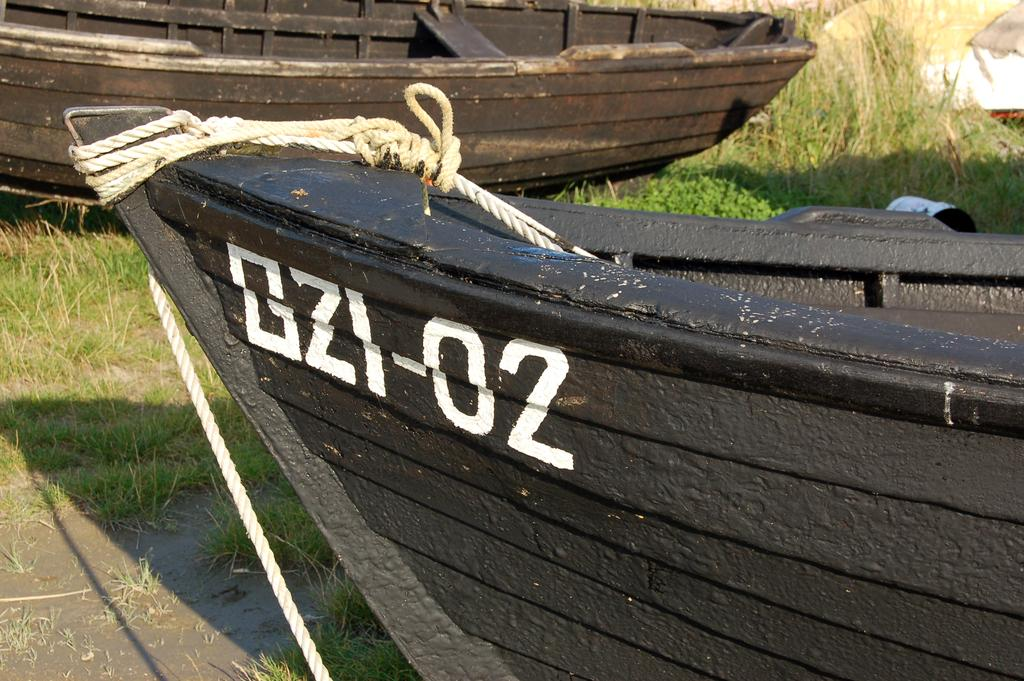What type of vehicles can be seen in the image? There are boats in the image. Where are the boats located? The boats are on the surface of something, likely water. What type of bushes can be seen growing in the hall in the image? There is no hall or bushes present in the image; it features boats on a surface, likely water. 